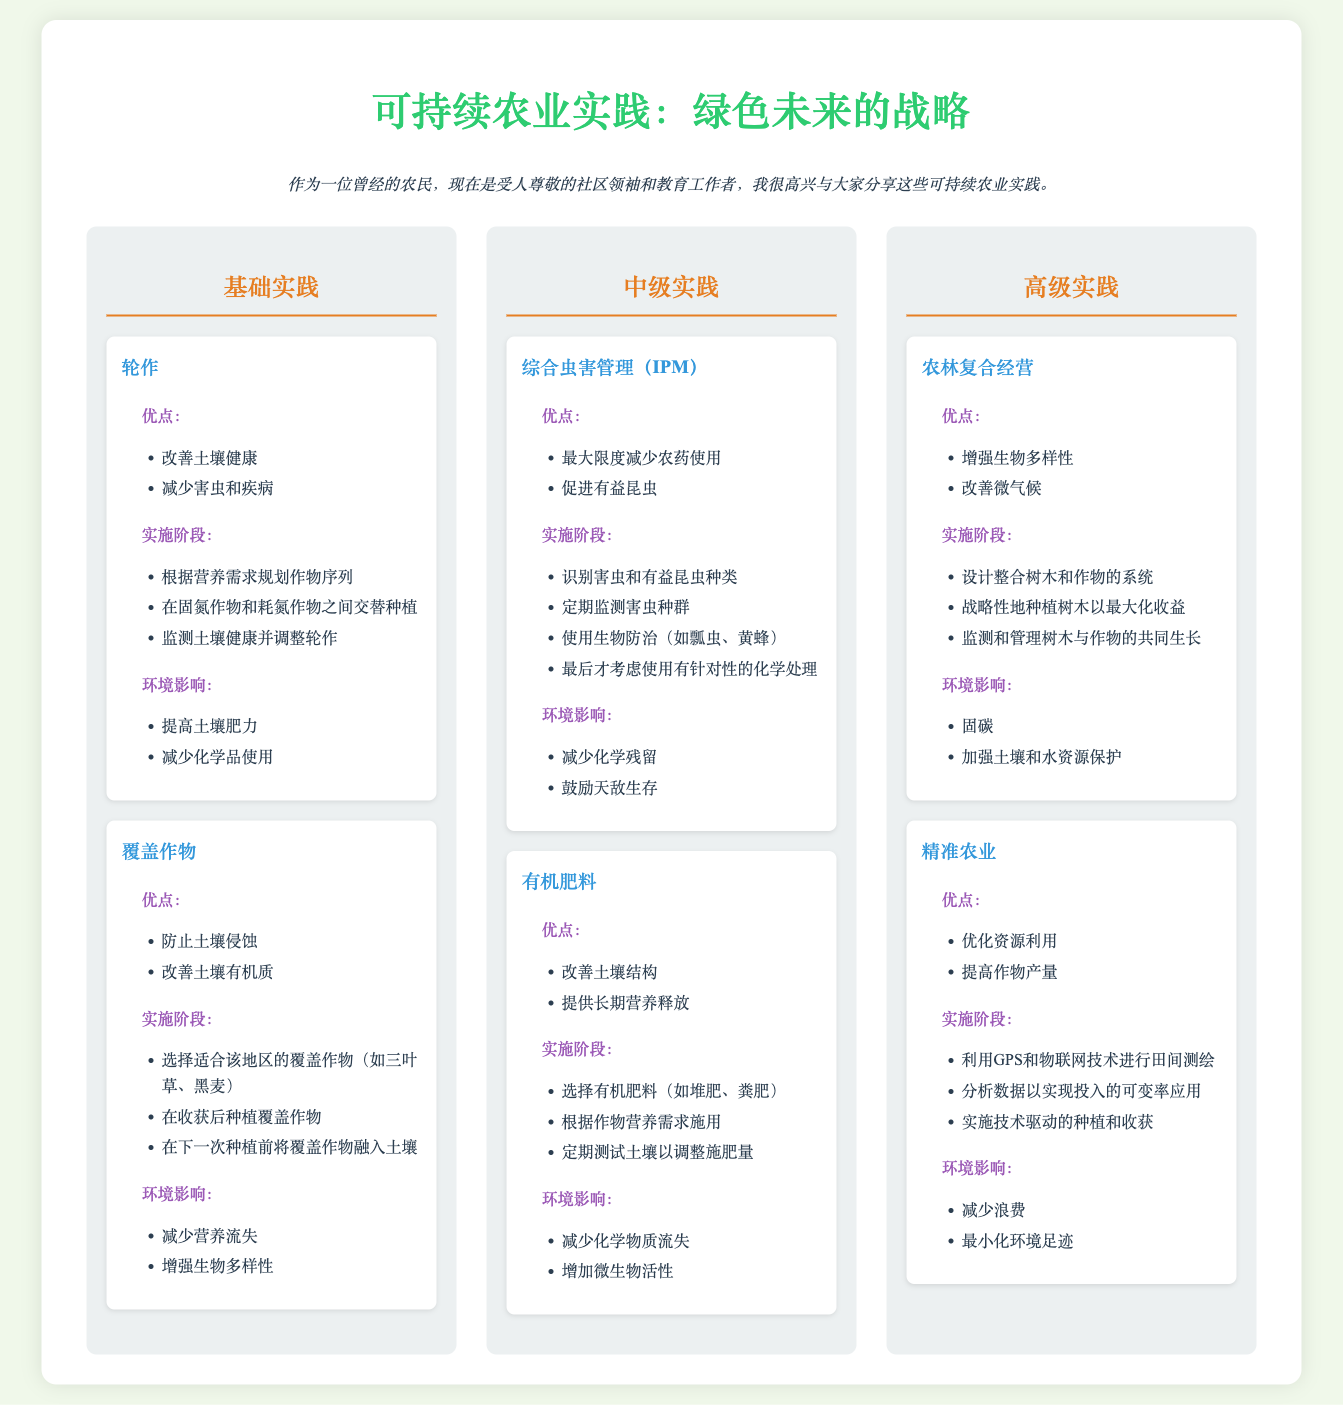What are the basic practices listed? The document lists "轮作" (Crop Rotation) and "覆盖作物" (Cover Crops) as basic practices.
Answer: 轮作, 覆盖作物 What is the main advantage of integrated pest management (IPM)? The main advantage of IPM is minimizing pesticide use.
Answer: 最大限度减少农药使用 Which advanced practice focuses on combining trees and crops? The advanced practice that focuses on combining trees and crops is "农林复合经营" (Agroforestry).
Answer: 农林复合经营 What kind of technology is used in precision agriculture? The technology used in precision agriculture includes GPS and Internet of Things (IoT).
Answer: GPS和物联网技术 How many intermediate practices are mentioned? The document mentions two intermediate practices.
Answer: 两个 What benefit does cover crops provide to the soil? Cover crops help prevent soil erosion.
Answer: 防止土壤侵蚀 What is a step in implementing crop rotation? One step in implementing crop rotation is planning crop sequences based on nutrient needs.
Answer: 根据营养需求规划作物序列 What is the primary environmental impact of organic fertilizers? The primary environmental impact of organic fertilizers is increasing microbial activity.
Answer: 增加微生物活性 What is the goal of agroforestry? The goal of agroforestry includes enhancing biodiversity.
Answer: 增强生物多样性 